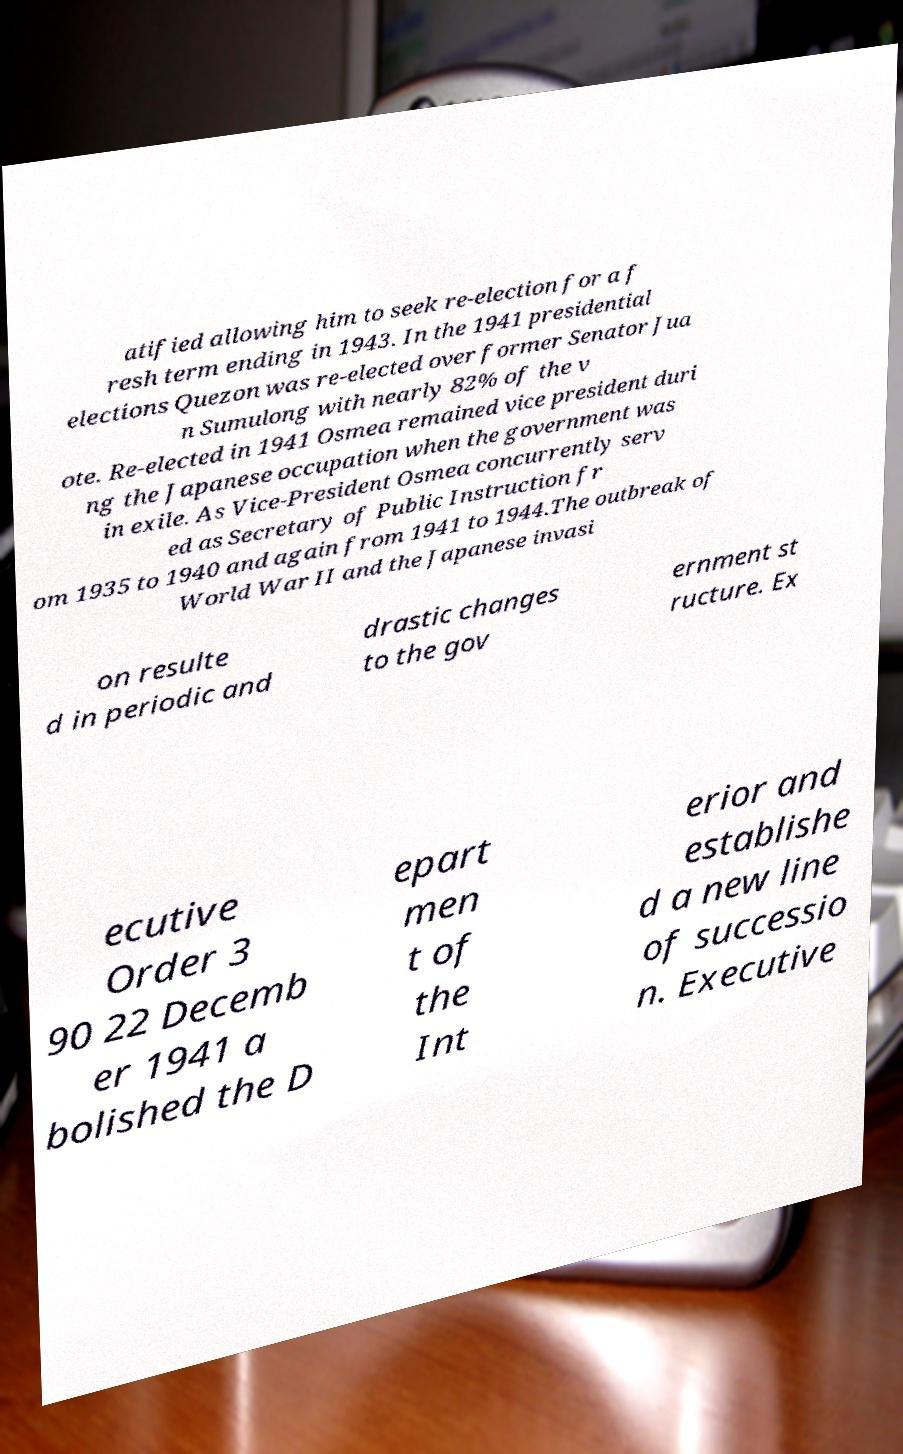There's text embedded in this image that I need extracted. Can you transcribe it verbatim? atified allowing him to seek re-election for a f resh term ending in 1943. In the 1941 presidential elections Quezon was re-elected over former Senator Jua n Sumulong with nearly 82% of the v ote. Re-elected in 1941 Osmea remained vice president duri ng the Japanese occupation when the government was in exile. As Vice-President Osmea concurrently serv ed as Secretary of Public Instruction fr om 1935 to 1940 and again from 1941 to 1944.The outbreak of World War II and the Japanese invasi on resulte d in periodic and drastic changes to the gov ernment st ructure. Ex ecutive Order 3 90 22 Decemb er 1941 a bolished the D epart men t of the Int erior and establishe d a new line of successio n. Executive 